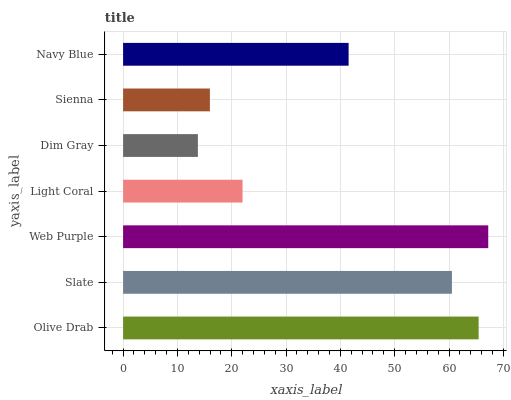Is Dim Gray the minimum?
Answer yes or no. Yes. Is Web Purple the maximum?
Answer yes or no. Yes. Is Slate the minimum?
Answer yes or no. No. Is Slate the maximum?
Answer yes or no. No. Is Olive Drab greater than Slate?
Answer yes or no. Yes. Is Slate less than Olive Drab?
Answer yes or no. Yes. Is Slate greater than Olive Drab?
Answer yes or no. No. Is Olive Drab less than Slate?
Answer yes or no. No. Is Navy Blue the high median?
Answer yes or no. Yes. Is Navy Blue the low median?
Answer yes or no. Yes. Is Sienna the high median?
Answer yes or no. No. Is Sienna the low median?
Answer yes or no. No. 